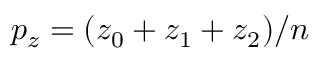Convert formula to latex. <formula><loc_0><loc_0><loc_500><loc_500>p _ { z } = ( z _ { 0 } + z _ { 1 } + z _ { 2 } ) / n</formula> 